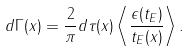Convert formula to latex. <formula><loc_0><loc_0><loc_500><loc_500>d \Gamma ( x ) = \frac { 2 } { \pi } d \tau ( x ) \left < \frac { \epsilon ( t _ { E } ) } { t _ { E } ( x ) } \right > .</formula> 